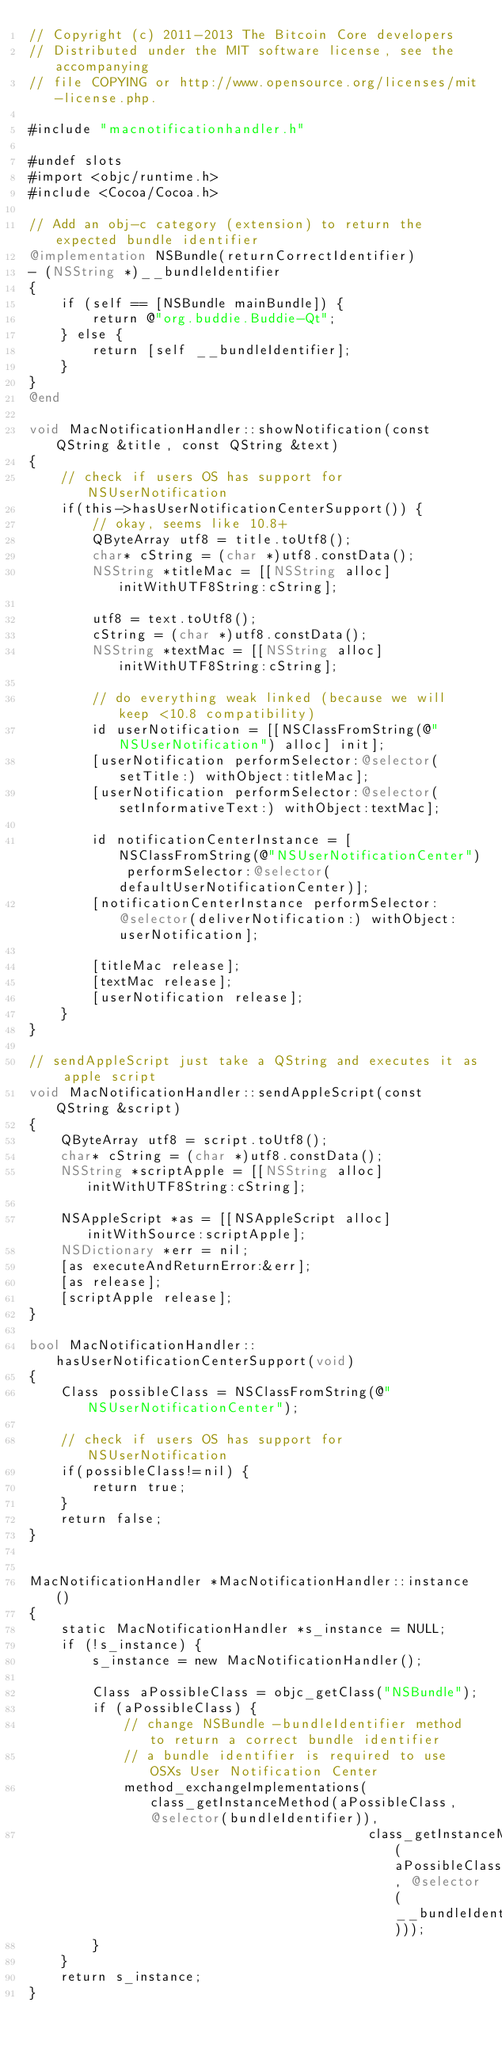Convert code to text. <code><loc_0><loc_0><loc_500><loc_500><_ObjectiveC_>// Copyright (c) 2011-2013 The Bitcoin Core developers
// Distributed under the MIT software license, see the accompanying
// file COPYING or http://www.opensource.org/licenses/mit-license.php.

#include "macnotificationhandler.h"

#undef slots
#import <objc/runtime.h>
#include <Cocoa/Cocoa.h>

// Add an obj-c category (extension) to return the expected bundle identifier
@implementation NSBundle(returnCorrectIdentifier)
- (NSString *)__bundleIdentifier
{
    if (self == [NSBundle mainBundle]) {
        return @"org.buddie.Buddie-Qt";
    } else {
        return [self __bundleIdentifier];
    }
}
@end

void MacNotificationHandler::showNotification(const QString &title, const QString &text)
{
    // check if users OS has support for NSUserNotification
    if(this->hasUserNotificationCenterSupport()) {
        // okay, seems like 10.8+
        QByteArray utf8 = title.toUtf8();
        char* cString = (char *)utf8.constData();
        NSString *titleMac = [[NSString alloc] initWithUTF8String:cString];

        utf8 = text.toUtf8();
        cString = (char *)utf8.constData();
        NSString *textMac = [[NSString alloc] initWithUTF8String:cString];

        // do everything weak linked (because we will keep <10.8 compatibility)
        id userNotification = [[NSClassFromString(@"NSUserNotification") alloc] init];
        [userNotification performSelector:@selector(setTitle:) withObject:titleMac];
        [userNotification performSelector:@selector(setInformativeText:) withObject:textMac];

        id notificationCenterInstance = [NSClassFromString(@"NSUserNotificationCenter") performSelector:@selector(defaultUserNotificationCenter)];
        [notificationCenterInstance performSelector:@selector(deliverNotification:) withObject:userNotification];

        [titleMac release];
        [textMac release];
        [userNotification release];
    }
}

// sendAppleScript just take a QString and executes it as apple script
void MacNotificationHandler::sendAppleScript(const QString &script)
{
    QByteArray utf8 = script.toUtf8();
    char* cString = (char *)utf8.constData();
    NSString *scriptApple = [[NSString alloc] initWithUTF8String:cString];

    NSAppleScript *as = [[NSAppleScript alloc] initWithSource:scriptApple];
    NSDictionary *err = nil;
    [as executeAndReturnError:&err];
    [as release];
    [scriptApple release];
}

bool MacNotificationHandler::hasUserNotificationCenterSupport(void)
{
    Class possibleClass = NSClassFromString(@"NSUserNotificationCenter");

    // check if users OS has support for NSUserNotification
    if(possibleClass!=nil) {
        return true;
    }
    return false;
}


MacNotificationHandler *MacNotificationHandler::instance()
{
    static MacNotificationHandler *s_instance = NULL;
    if (!s_instance) {
        s_instance = new MacNotificationHandler();
        
        Class aPossibleClass = objc_getClass("NSBundle");
        if (aPossibleClass) {
            // change NSBundle -bundleIdentifier method to return a correct bundle identifier
            // a bundle identifier is required to use OSXs User Notification Center
            method_exchangeImplementations(class_getInstanceMethod(aPossibleClass, @selector(bundleIdentifier)),
                                           class_getInstanceMethod(aPossibleClass, @selector(__bundleIdentifier)));
        }
    }
    return s_instance;
}
</code> 